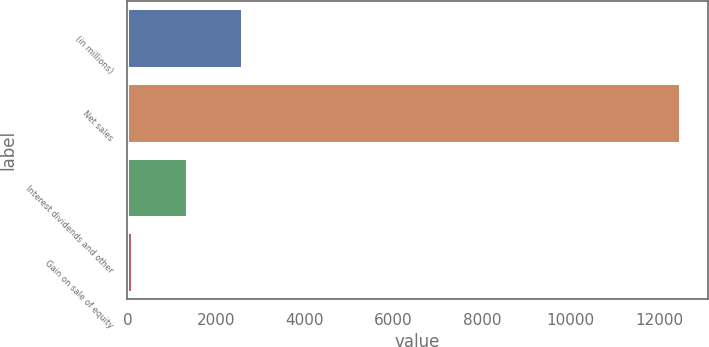<chart> <loc_0><loc_0><loc_500><loc_500><bar_chart><fcel>(in millions)<fcel>Net sales<fcel>Interest dividends and other<fcel>Gain on sale of equity<nl><fcel>2576.8<fcel>12480<fcel>1338.9<fcel>101<nl></chart> 